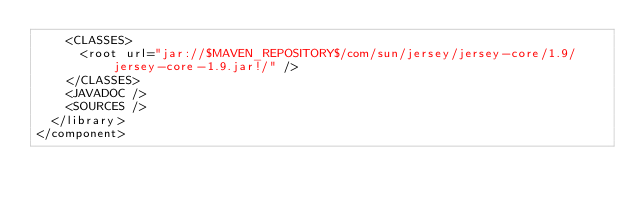Convert code to text. <code><loc_0><loc_0><loc_500><loc_500><_XML_>    <CLASSES>
      <root url="jar://$MAVEN_REPOSITORY$/com/sun/jersey/jersey-core/1.9/jersey-core-1.9.jar!/" />
    </CLASSES>
    <JAVADOC />
    <SOURCES />
  </library>
</component></code> 